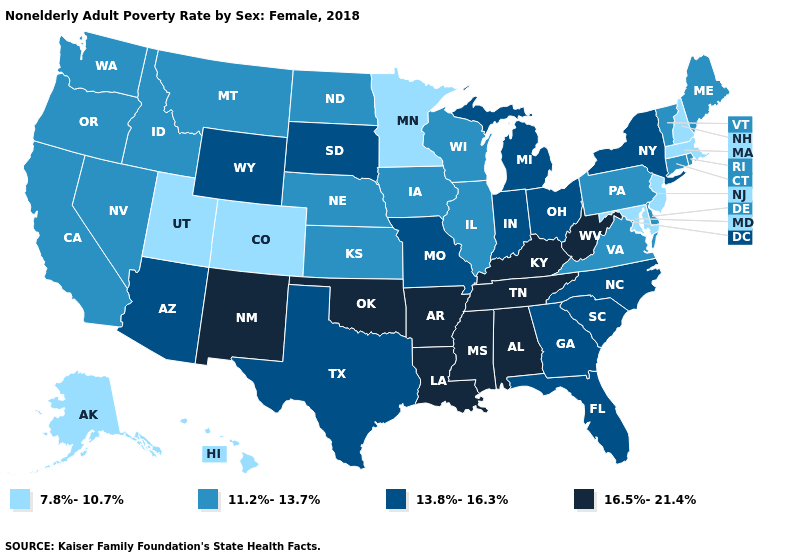Name the states that have a value in the range 7.8%-10.7%?
Short answer required. Alaska, Colorado, Hawaii, Maryland, Massachusetts, Minnesota, New Hampshire, New Jersey, Utah. What is the highest value in the USA?
Write a very short answer. 16.5%-21.4%. Does Maine have the lowest value in the Northeast?
Write a very short answer. No. Does South Carolina have the highest value in the USA?
Concise answer only. No. Does the map have missing data?
Short answer required. No. Among the states that border Wyoming , which have the lowest value?
Write a very short answer. Colorado, Utah. What is the value of Nevada?
Concise answer only. 11.2%-13.7%. Is the legend a continuous bar?
Answer briefly. No. What is the lowest value in the USA?
Give a very brief answer. 7.8%-10.7%. Among the states that border Oregon , which have the highest value?
Short answer required. California, Idaho, Nevada, Washington. What is the value of Connecticut?
Write a very short answer. 11.2%-13.7%. Name the states that have a value in the range 16.5%-21.4%?
Write a very short answer. Alabama, Arkansas, Kentucky, Louisiana, Mississippi, New Mexico, Oklahoma, Tennessee, West Virginia. Which states have the highest value in the USA?
Give a very brief answer. Alabama, Arkansas, Kentucky, Louisiana, Mississippi, New Mexico, Oklahoma, Tennessee, West Virginia. Among the states that border Rhode Island , which have the highest value?
Quick response, please. Connecticut. 